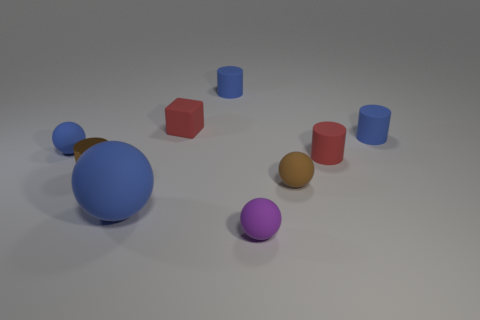Subtract 1 cylinders. How many cylinders are left? 3 Add 1 small brown balls. How many objects exist? 10 Subtract all cylinders. How many objects are left? 5 Subtract all big red shiny balls. Subtract all red blocks. How many objects are left? 8 Add 6 blue balls. How many blue balls are left? 8 Add 3 small gray shiny objects. How many small gray shiny objects exist? 3 Subtract 0 purple cubes. How many objects are left? 9 